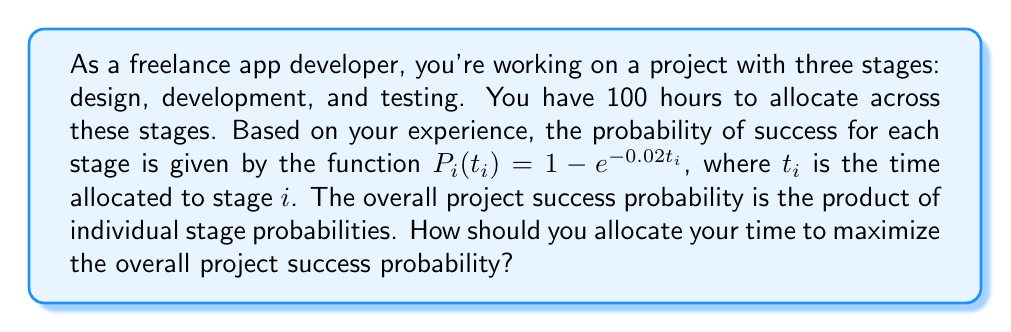Could you help me with this problem? Let's approach this problem step-by-step:

1) The success probability for each stage is given by $P_i(t_i) = 1 - e^{-0.02t_i}$.

2) The overall project success probability is the product of individual stage probabilities:

   $P_{total} = P_1(t_1) \cdot P_2(t_2) \cdot P_3(t_3)$

3) We need to maximize $P_{total}$ subject to the constraint $t_1 + t_2 + t_3 = 100$.

4) We can use the method of Lagrange multipliers. Let's define:

   $L(t_1, t_2, t_3, \lambda) = (1-e^{-0.02t_1})(1-e^{-0.02t_2})(1-e^{-0.02t_3}) - \lambda(t_1 + t_2 + t_3 - 100)$

5) Taking partial derivatives and setting them to zero:

   $\frac{\partial L}{\partial t_1} = 0.02e^{-0.02t_1}(1-e^{-0.02t_2})(1-e^{-0.02t_3}) - \lambda = 0$
   $\frac{\partial L}{\partial t_2} = 0.02e^{-0.02t_2}(1-e^{-0.02t_1})(1-e^{-0.02t_3}) - \lambda = 0$
   $\frac{\partial L}{\partial t_3} = 0.02e^{-0.02t_3}(1-e^{-0.02t_1})(1-e^{-0.02t_2}) - \lambda = 0$
   $\frac{\partial L}{\partial \lambda} = t_1 + t_2 + t_3 - 100 = 0$

6) From the first three equations, we can deduce that $e^{-0.02t_1} = e^{-0.02t_2} = e^{-0.02t_3}$, which implies $t_1 = t_2 = t_3$.

7) Given the constraint $t_1 + t_2 + t_3 = 100$, we can conclude that $t_1 = t_2 = t_3 = \frac{100}{3} \approx 33.33$ hours.

This allocation maximizes the overall project success probability.
Answer: The optimal allocation is approximately 33.33 hours for each stage: design, development, and testing. 